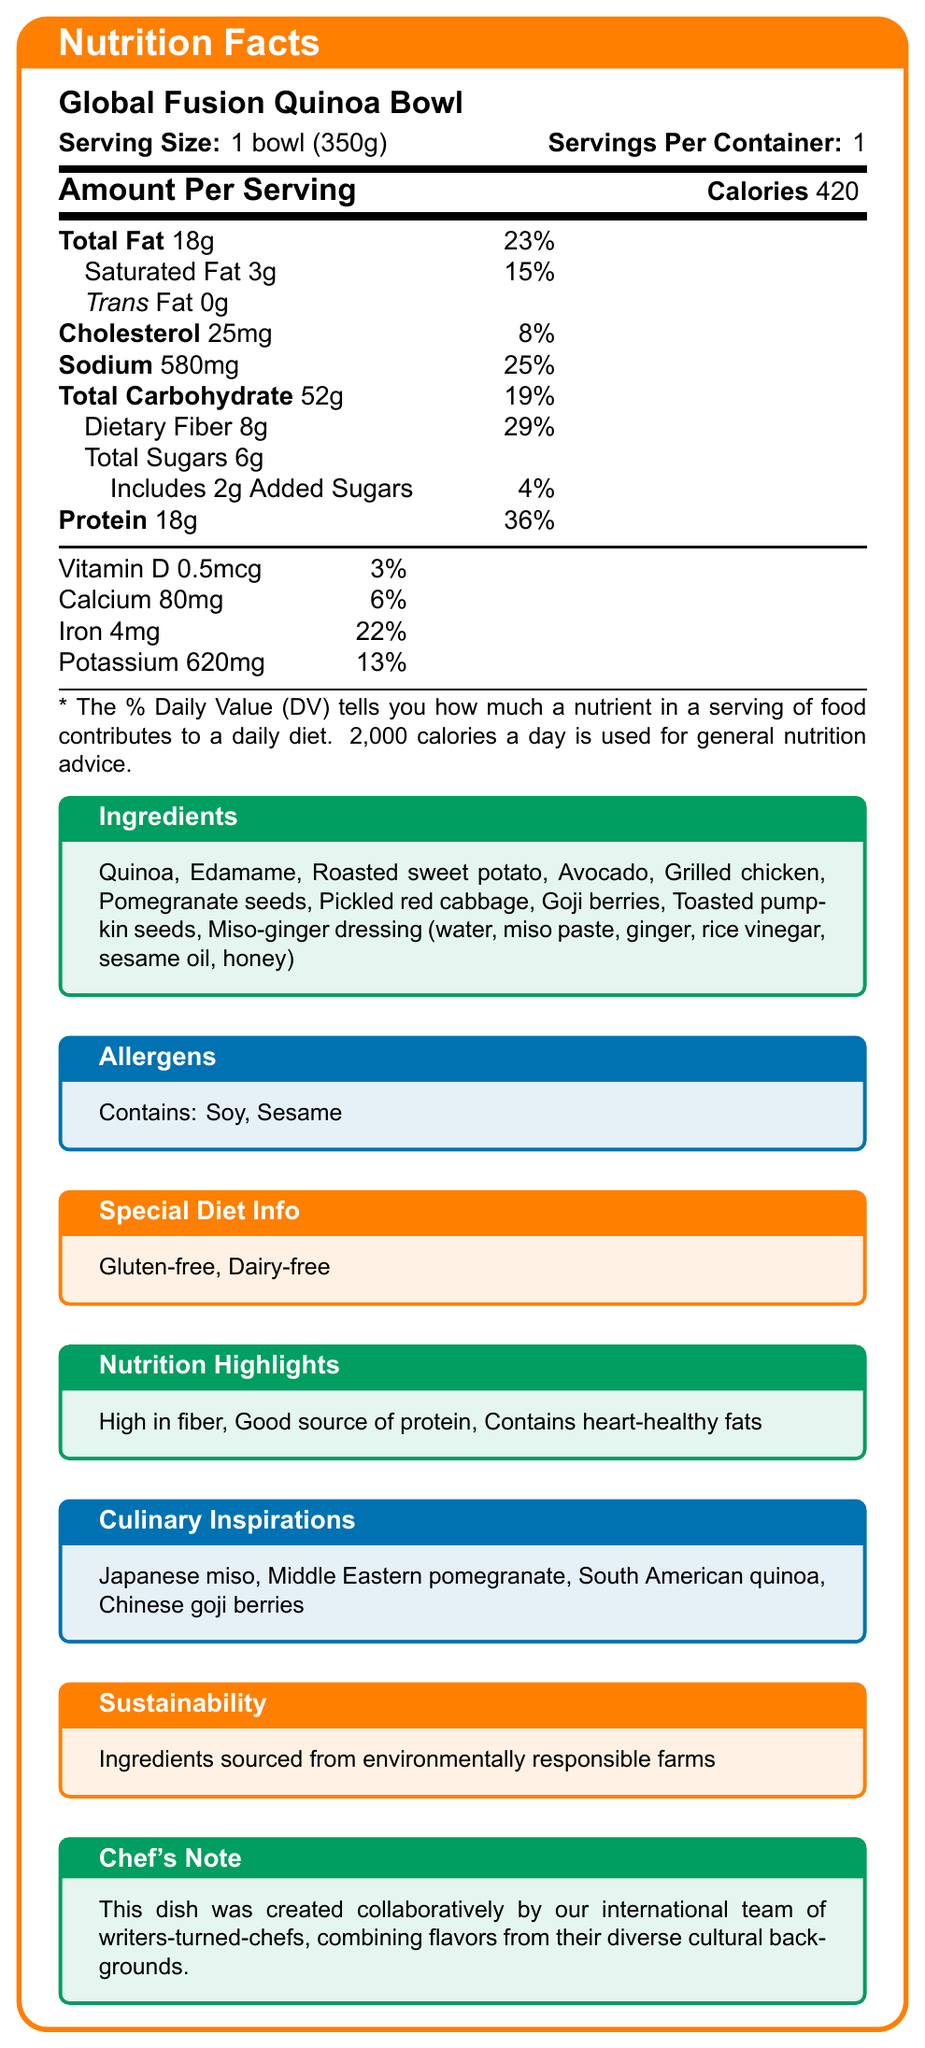what is the serving size of the Global Fusion Quinoa Bowl? The serving size is listed as "1 bowl (350g)" in the document.
Answer: 1 bowl (350g) how many calories are in one serving of the Global Fusion Quinoa Bowl? The document states that one serving contains 420 calories.
Answer: 420 calories what are the main ingredients in the Global Fusion Quinoa Bowl? The ingredients list under the title "Ingredients" details all the main components of the dish.
Answer: Quinoa, Edamame, Roasted sweet potato, Avocado, Grilled chicken, Pomegranate seeds, Pickled red cabbage, Goji berries, Toasted pumpkin seeds, Miso-ginger dressing how much protein is there per serving? The document states that there are 18 grams of protein per serving.
Answer: 18g what percentage of daily value does the sodium content represent? The document states that the sodium amount is 580mg, equating to 25% of the daily value.
Answer: 25% which of the following allergens are present in the Global Fusion Quinoa Bowl? A. Gluten B. Dairy C. Soy D. Nuts The allergens section lists "Soy" under allergens present in the dish.
Answer: C. Soy what is the daily value percentage of iron in one serving? A. 6% B. 22% C. 15% D. 13% The document states that there is 4mg of iron, which is 22% of the daily value.
Answer: B. 22% is the Global Fusion Quinoa Bowl gluten-free? The "Special Diet Info" section mentions that the dish is gluten-free.
Answer: Yes does the dish contain trans fats? The document clearly states that the trans fat content is 0g, implying that there are no trans fats.
Answer: No summarize the entire document's main points. The document thoroughly describes the nutritional content and additional highlights of the Global Fusion Quinoa Bowl, drawing on diverse global culinary inspirations and focusing on sustainability.
Answer: The document provides a detailed Nutrition Facts Label for the "Global Fusion Quinoa Bowl." It includes information on serving size, calories, detailed nutrient composition, ingredient list, allergen information, special diet information, nutrition highlights, culinary inspirations, sustainability efforts, and a chef's note. The dish is high in fiber, a good source of protein, contains heart-healthy fats, and is both gluten-free and dairy-free. what is the source of dietary fiber in this dish? While the document lists various ingredients, it doesn't specify which exact ingredient provides the dietary fiber.
Answer: Not enough information what are the culinary inspirations for the Global Fusion Quinoa Bowl? The document outlines these inspirations under the section "Culinary Inspirations."
Answer: Japanese miso, Middle Eastern pomegranate, South American quinoa, Chinese goji berries 